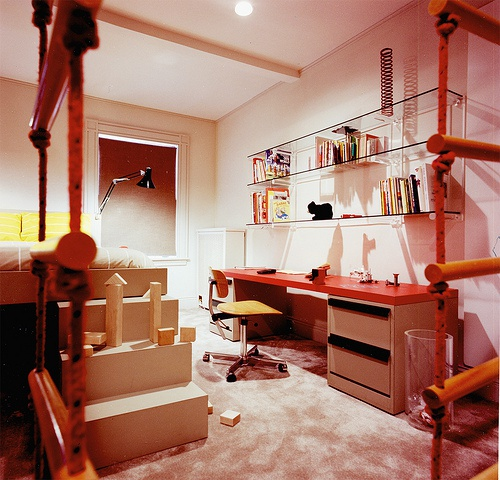Describe the objects in this image and their specific colors. I can see book in tan, lightgray, and brown tones, bed in tan, brown, beige, maroon, and red tones, bed in tan, maroon, and beige tones, chair in tan, black, maroon, and brown tones, and book in tan, lightgray, darkgray, and brown tones in this image. 